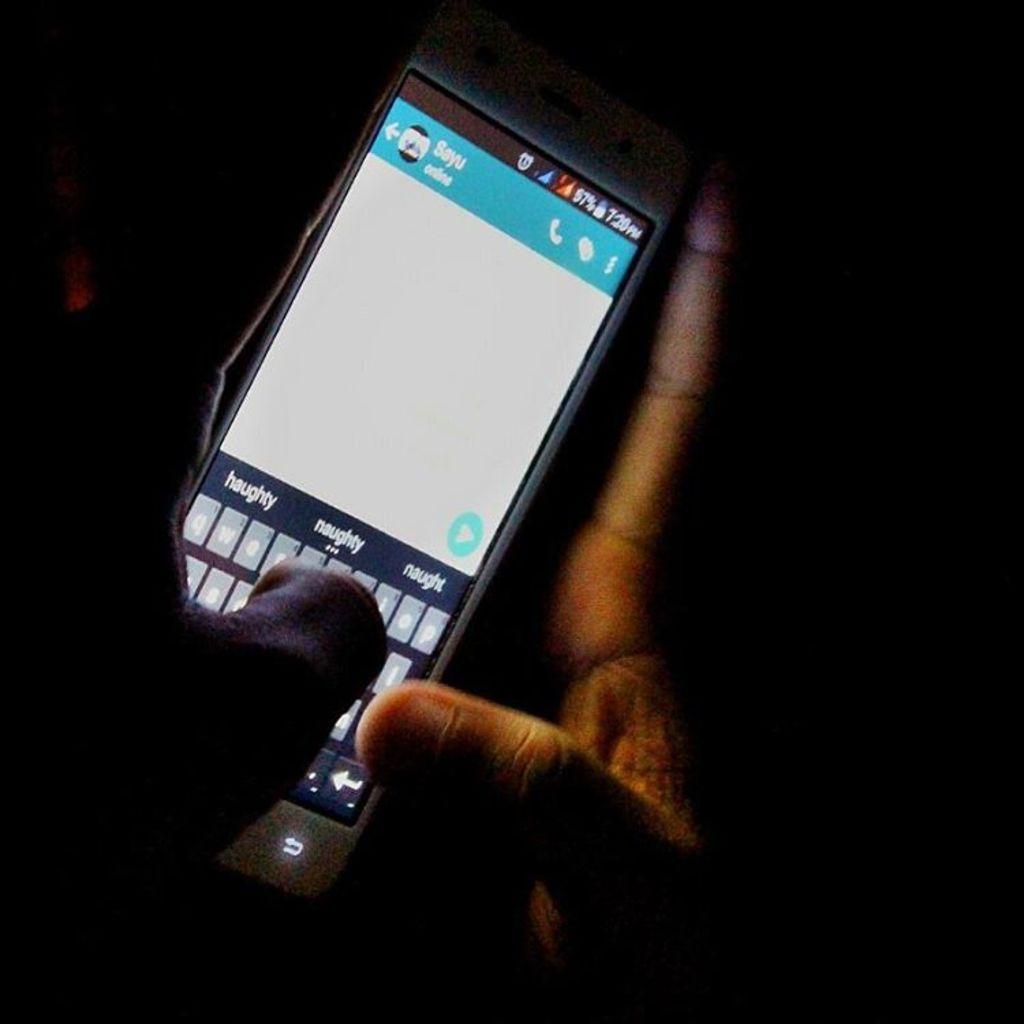What is the first text suggestion on the phone?
Provide a short and direct response. Haughty. What time is displayed on his phone?
Your answer should be compact. 7:20. 